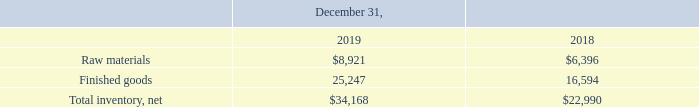Note 5. Inventory, Net
The components of inventory, net are as follows (in thousands):
What was the amount of raw materials in 2019?
Answer scale should be: thousand. $8,921. What was the amount of finished goods in 2018?
Answer scale should be: thousand. 16,594. Which years does the table provide information for net inventory? 2019, 2018. What was the change in raw materials between 2018 and 2019?
Answer scale should be: thousand. 8,921-6,396
Answer: 2525. What was the change in finished goods between 2018 and 2019?
Answer scale should be: thousand. 25,247-16,594
Answer: 8653. What was the percentage change in the net total inventory between 2018 and 2019?
Answer scale should be: percent. (34,168-22,990)/22,990
Answer: 48.62. 